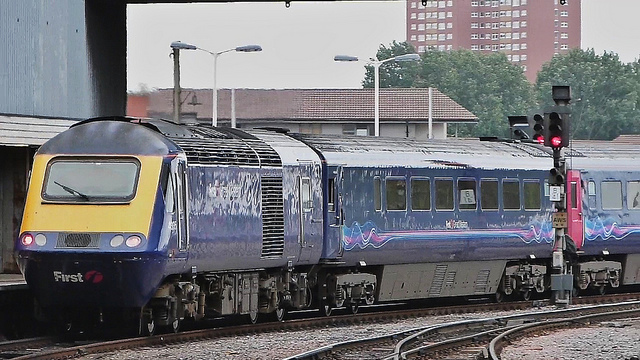<image>What is hanging on the front of the middle train? I don't know what is hanging on the front of the middle train. It could be a signal light, a door, or graffiti. What is hanging on the front of the middle train? I am not sure what is hanging on the front of the middle train. It can be seen 'signal light', 'door', 'graffiti', 'stop light', 'streetlight', or 'handle'. 